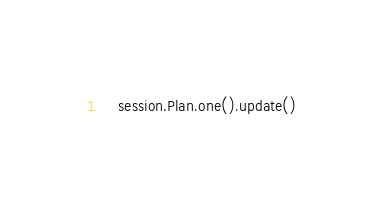Convert code to text. <code><loc_0><loc_0><loc_500><loc_500><_Python_>    session.Plan.one().update()
</code> 